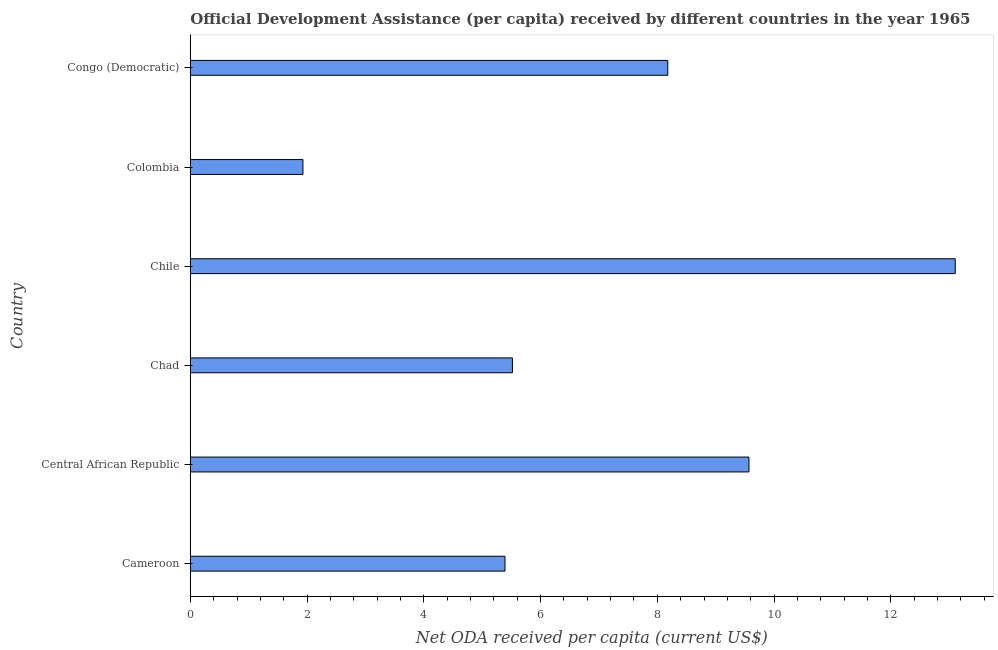Does the graph contain any zero values?
Your response must be concise. No. Does the graph contain grids?
Your answer should be compact. No. What is the title of the graph?
Offer a very short reply. Official Development Assistance (per capita) received by different countries in the year 1965. What is the label or title of the X-axis?
Offer a very short reply. Net ODA received per capita (current US$). What is the label or title of the Y-axis?
Offer a terse response. Country. What is the net oda received per capita in Congo (Democratic)?
Your answer should be compact. 8.18. Across all countries, what is the maximum net oda received per capita?
Give a very brief answer. 13.1. Across all countries, what is the minimum net oda received per capita?
Your response must be concise. 1.93. What is the sum of the net oda received per capita?
Your answer should be very brief. 43.69. What is the difference between the net oda received per capita in Central African Republic and Chile?
Your answer should be very brief. -3.53. What is the average net oda received per capita per country?
Provide a short and direct response. 7.28. What is the median net oda received per capita?
Ensure brevity in your answer.  6.85. What is the ratio of the net oda received per capita in Chile to that in Colombia?
Ensure brevity in your answer.  6.79. Is the net oda received per capita in Cameroon less than that in Colombia?
Give a very brief answer. No. What is the difference between the highest and the second highest net oda received per capita?
Offer a very short reply. 3.53. What is the difference between the highest and the lowest net oda received per capita?
Your response must be concise. 11.17. In how many countries, is the net oda received per capita greater than the average net oda received per capita taken over all countries?
Ensure brevity in your answer.  3. How many bars are there?
Your answer should be very brief. 6. Are all the bars in the graph horizontal?
Your answer should be compact. Yes. How many countries are there in the graph?
Offer a terse response. 6. What is the difference between two consecutive major ticks on the X-axis?
Give a very brief answer. 2. Are the values on the major ticks of X-axis written in scientific E-notation?
Your answer should be compact. No. What is the Net ODA received per capita (current US$) of Cameroon?
Ensure brevity in your answer.  5.39. What is the Net ODA received per capita (current US$) of Central African Republic?
Offer a terse response. 9.57. What is the Net ODA received per capita (current US$) of Chad?
Ensure brevity in your answer.  5.52. What is the Net ODA received per capita (current US$) in Chile?
Give a very brief answer. 13.1. What is the Net ODA received per capita (current US$) in Colombia?
Your response must be concise. 1.93. What is the Net ODA received per capita (current US$) in Congo (Democratic)?
Ensure brevity in your answer.  8.18. What is the difference between the Net ODA received per capita (current US$) in Cameroon and Central African Republic?
Give a very brief answer. -4.18. What is the difference between the Net ODA received per capita (current US$) in Cameroon and Chad?
Your answer should be compact. -0.13. What is the difference between the Net ODA received per capita (current US$) in Cameroon and Chile?
Keep it short and to the point. -7.71. What is the difference between the Net ODA received per capita (current US$) in Cameroon and Colombia?
Ensure brevity in your answer.  3.46. What is the difference between the Net ODA received per capita (current US$) in Cameroon and Congo (Democratic)?
Your answer should be compact. -2.79. What is the difference between the Net ODA received per capita (current US$) in Central African Republic and Chad?
Ensure brevity in your answer.  4.05. What is the difference between the Net ODA received per capita (current US$) in Central African Republic and Chile?
Offer a very short reply. -3.53. What is the difference between the Net ODA received per capita (current US$) in Central African Republic and Colombia?
Provide a succinct answer. 7.64. What is the difference between the Net ODA received per capita (current US$) in Central African Republic and Congo (Democratic)?
Your response must be concise. 1.39. What is the difference between the Net ODA received per capita (current US$) in Chad and Chile?
Offer a very short reply. -7.59. What is the difference between the Net ODA received per capita (current US$) in Chad and Colombia?
Offer a very short reply. 3.59. What is the difference between the Net ODA received per capita (current US$) in Chad and Congo (Democratic)?
Your answer should be very brief. -2.66. What is the difference between the Net ODA received per capita (current US$) in Chile and Colombia?
Your answer should be very brief. 11.17. What is the difference between the Net ODA received per capita (current US$) in Chile and Congo (Democratic)?
Make the answer very short. 4.92. What is the difference between the Net ODA received per capita (current US$) in Colombia and Congo (Democratic)?
Offer a terse response. -6.25. What is the ratio of the Net ODA received per capita (current US$) in Cameroon to that in Central African Republic?
Offer a terse response. 0.56. What is the ratio of the Net ODA received per capita (current US$) in Cameroon to that in Chile?
Your answer should be very brief. 0.41. What is the ratio of the Net ODA received per capita (current US$) in Cameroon to that in Colombia?
Ensure brevity in your answer.  2.79. What is the ratio of the Net ODA received per capita (current US$) in Cameroon to that in Congo (Democratic)?
Offer a terse response. 0.66. What is the ratio of the Net ODA received per capita (current US$) in Central African Republic to that in Chad?
Ensure brevity in your answer.  1.73. What is the ratio of the Net ODA received per capita (current US$) in Central African Republic to that in Chile?
Your answer should be compact. 0.73. What is the ratio of the Net ODA received per capita (current US$) in Central African Republic to that in Colombia?
Your answer should be very brief. 4.96. What is the ratio of the Net ODA received per capita (current US$) in Central African Republic to that in Congo (Democratic)?
Your response must be concise. 1.17. What is the ratio of the Net ODA received per capita (current US$) in Chad to that in Chile?
Your response must be concise. 0.42. What is the ratio of the Net ODA received per capita (current US$) in Chad to that in Colombia?
Provide a short and direct response. 2.86. What is the ratio of the Net ODA received per capita (current US$) in Chad to that in Congo (Democratic)?
Keep it short and to the point. 0.68. What is the ratio of the Net ODA received per capita (current US$) in Chile to that in Colombia?
Keep it short and to the point. 6.79. What is the ratio of the Net ODA received per capita (current US$) in Chile to that in Congo (Democratic)?
Provide a succinct answer. 1.6. What is the ratio of the Net ODA received per capita (current US$) in Colombia to that in Congo (Democratic)?
Offer a very short reply. 0.24. 